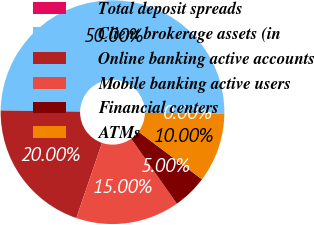Convert chart to OTSL. <chart><loc_0><loc_0><loc_500><loc_500><pie_chart><fcel>Total deposit spreads<fcel>Client brokerage assets (in<fcel>Online banking active accounts<fcel>Mobile banking active users<fcel>Financial centers<fcel>ATMs<nl><fcel>0.0%<fcel>50.0%<fcel>20.0%<fcel>15.0%<fcel>5.0%<fcel>10.0%<nl></chart> 